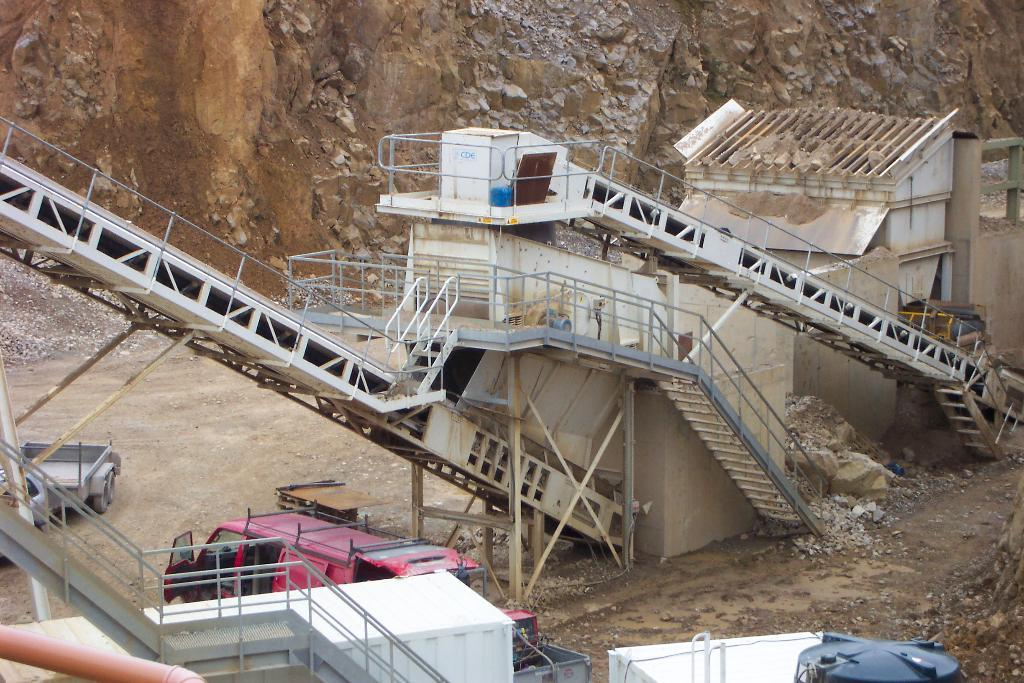What types of objects can be seen in the image? There are vehicles, machinery, stairs, a shed, stones, a railing, and a tank in the image. Can you describe the setting of the image? The image appears to be set in an industrial or construction site, given the presence of machinery, a shed, and a tank. What type of structure is present in the image? There is a shed in the image. What might be used for support or safety in the image? The railing in the image might be used for support or safety. What can be seen in the background of the image? There is a rock in the background of the image. What type of reward can be seen in the image? There is no reward present in the image. Can you tell me what kind of drink is being served in the image? There is no drink being served in the image. 